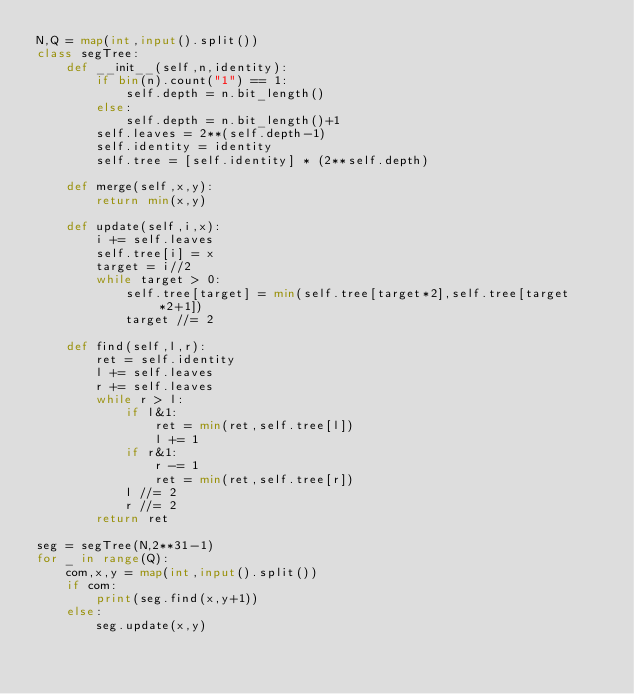<code> <loc_0><loc_0><loc_500><loc_500><_Python_>N,Q = map(int,input().split())
class segTree:
    def __init__(self,n,identity):
        if bin(n).count("1") == 1:
            self.depth = n.bit_length()
        else:
            self.depth = n.bit_length()+1
        self.leaves = 2**(self.depth-1)
        self.identity = identity
        self.tree = [self.identity] * (2**self.depth)
    
    def merge(self,x,y):
        return min(x,y)
    
    def update(self,i,x):
        i += self.leaves
        self.tree[i] = x
        target = i//2
        while target > 0:
            self.tree[target] = min(self.tree[target*2],self.tree[target*2+1])
            target //= 2
    
    def find(self,l,r):
        ret = self.identity
        l += self.leaves
        r += self.leaves
        while r > l:
            if l&1:
                ret = min(ret,self.tree[l])
                l += 1
            if r&1:
                r -= 1
                ret = min(ret,self.tree[r])
            l //= 2
            r //= 2
        return ret

seg = segTree(N,2**31-1)
for _ in range(Q):
    com,x,y = map(int,input().split())
    if com:
        print(seg.find(x,y+1))
    else:
        seg.update(x,y)








</code> 